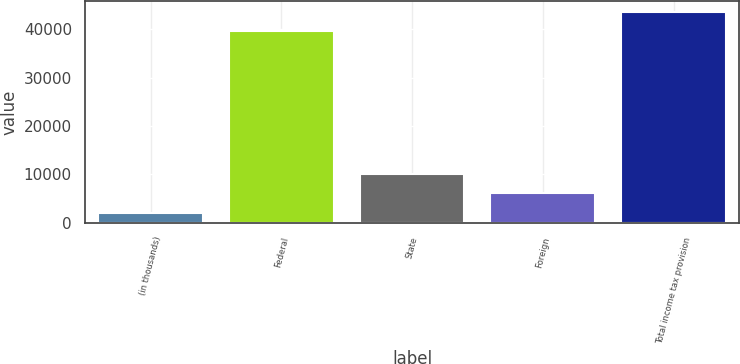<chart> <loc_0><loc_0><loc_500><loc_500><bar_chart><fcel>(in thousands)<fcel>Federal<fcel>State<fcel>Foreign<fcel>Total income tax provision<nl><fcel>2009<fcel>39636<fcel>10068.6<fcel>6038.8<fcel>43665.8<nl></chart> 